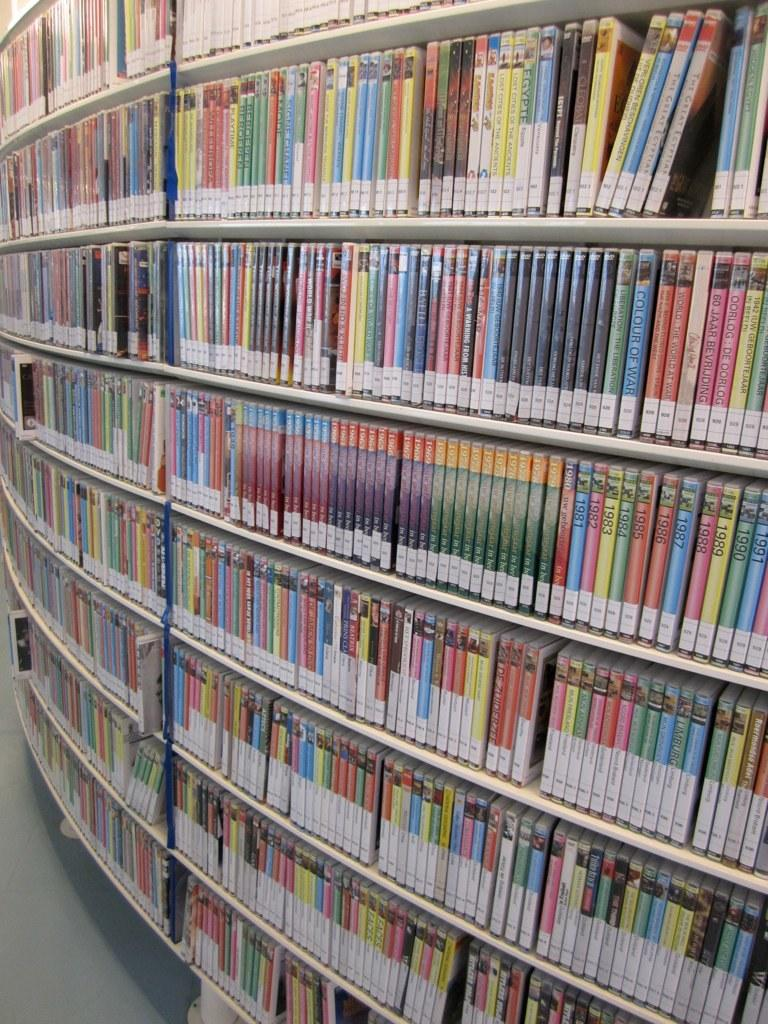What objects can be seen in the image? There are books in the image. Where are the books located? The books are placed on a bookshelf. What type of milk is being poured into the books in the image? There is no milk or pouring action present in the image; it only features books on a bookshelf. 